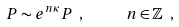Convert formula to latex. <formula><loc_0><loc_0><loc_500><loc_500>P \sim e ^ { n \kappa } P \ , \quad \ \ n \in \mathbb { Z } \ ,</formula> 